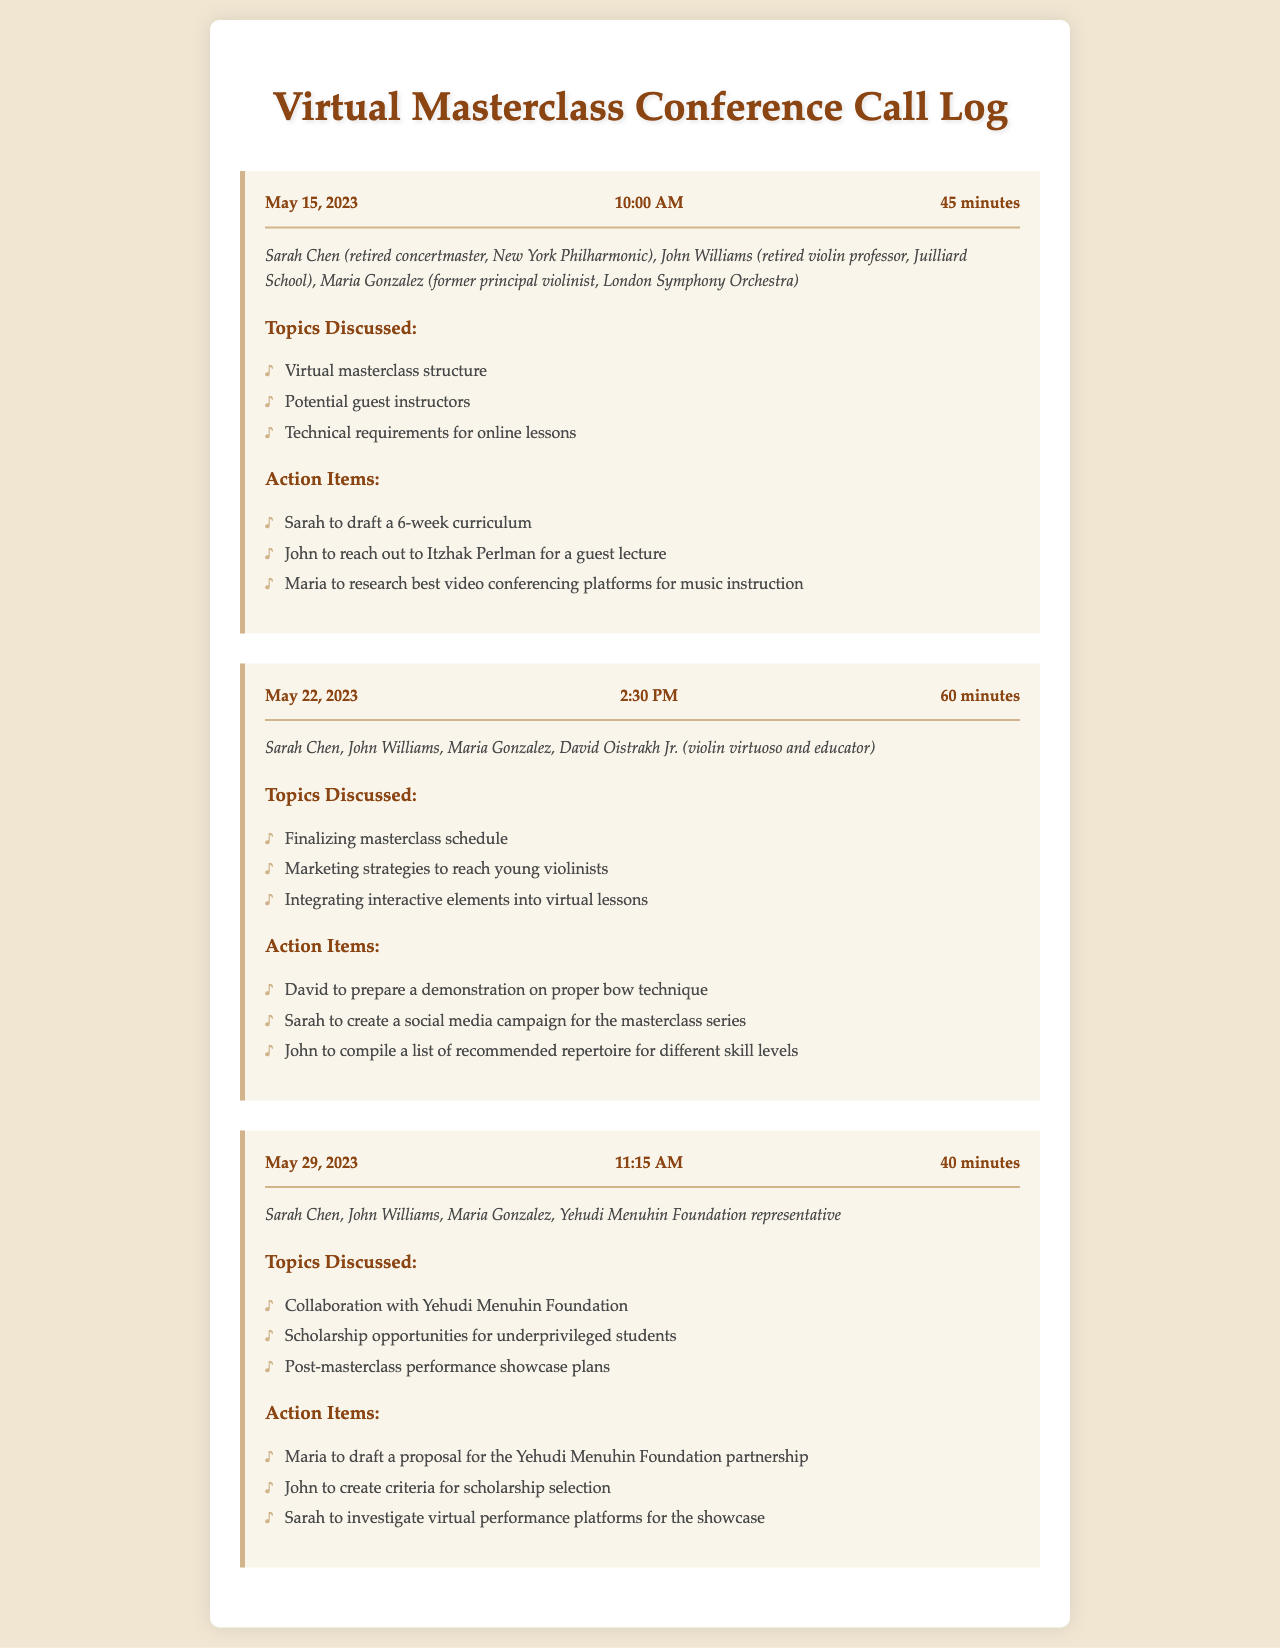What is the date of the first conference call? The first conference call occurred on May 15, 2023, as mentioned in the document.
Answer: May 15, 2023 Who reached out to Itzhak Perlman for a guest lecture? The document states that John Williams was responsible for reaching out to Itzhak Perlman.
Answer: John What is the duration of the second conference call? The duration of the second conference call is specified as 60 minutes in the document.
Answer: 60 minutes Which participant prepared a demonstration on proper bow technique? David Oistrakh Jr. is mentioned in the action items as preparing a demonstration on proper bow technique.
Answer: David Oistrakh Jr What was discussed in the call with the Yehudi Menuhin Foundation representative? The topics discussed included collaboration with the Yehudi Menuhin Foundation and scholarship opportunities, among others.
Answer: Collaboration with Yehudi Menuhin Foundation What is one of the action items for Sarah Chen? Sarah Chen's action items included drafting a 6-week curriculum and creating a social media campaign for the masterclass series.
Answer: Draft a 6-week curriculum How many total calls are logged in the document? The document lists a total of three conference calls.
Answer: Three Which organization was concerned with scholarship opportunities for underprivileged students? The document highlights that scholarship opportunities were discussed with the Yehudi Menuhin Foundation representative.
Answer: Yehudi Menuhin Foundation 